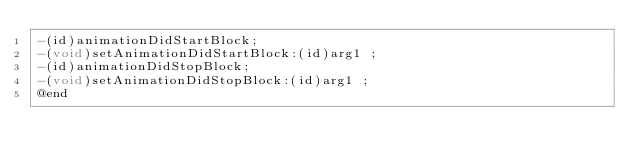<code> <loc_0><loc_0><loc_500><loc_500><_C_>-(id)animationDidStartBlock;
-(void)setAnimationDidStartBlock:(id)arg1 ;
-(id)animationDidStopBlock;
-(void)setAnimationDidStopBlock:(id)arg1 ;
@end

</code> 